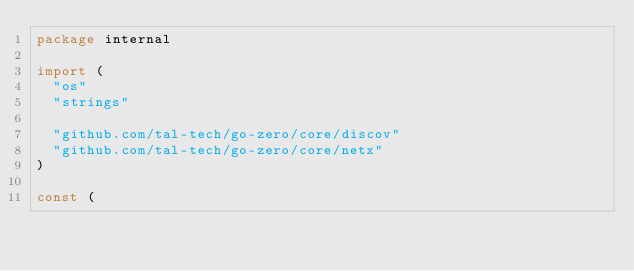<code> <loc_0><loc_0><loc_500><loc_500><_Go_>package internal

import (
	"os"
	"strings"

	"github.com/tal-tech/go-zero/core/discov"
	"github.com/tal-tech/go-zero/core/netx"
)

const (</code> 